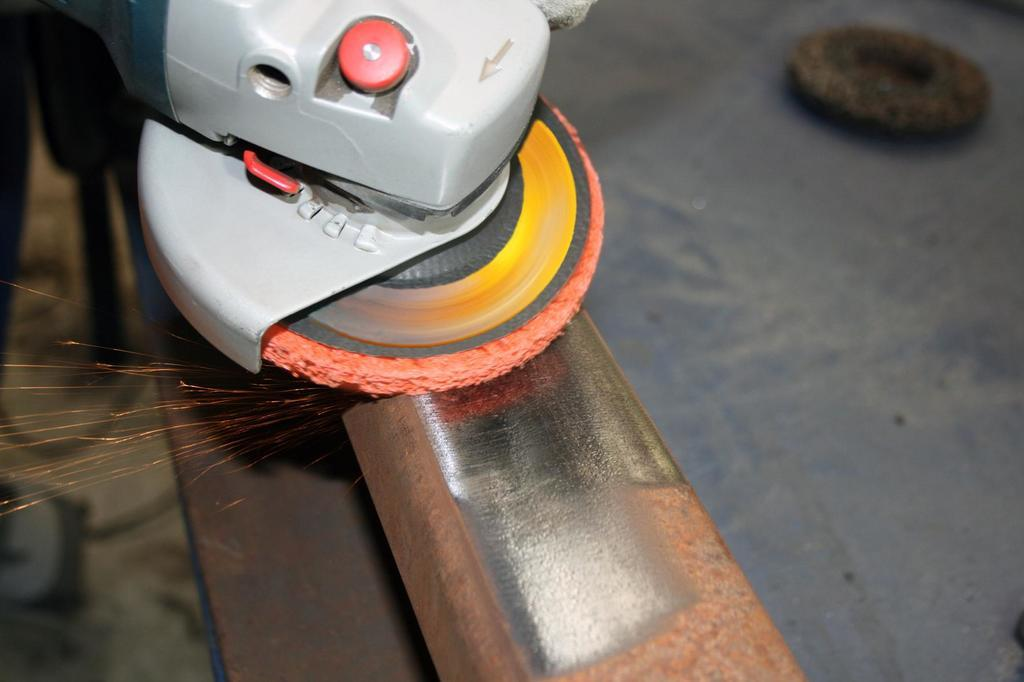What tool is featured in the image? There is an angle grinder in the image. How is the angle grinder positioned? The angle grinder is on a rod. Can you describe anything visible in the background of the image? There is an object in the background of the image. What type of jam is being spread on the finger in the image? There is no jam or finger present in the image; it features an angle grinder on a rod with an object in the background. 